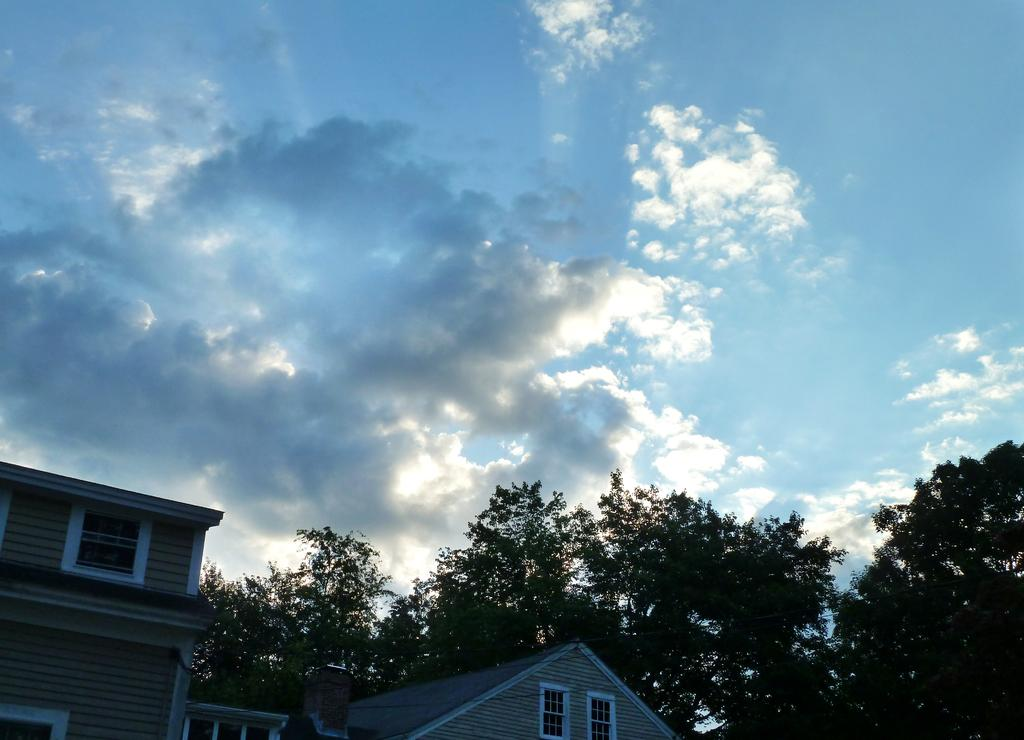What type of structures can be seen in the image? There are buildings in the image. What type of vegetation is present in the image? There are trees in the image. What can be seen in the sky in the image? There are clouds visible in the sky in the image. What is the purpose of the twig in the image? There is no twig present in the image. Can you tell me the account number of the building in the image? There is no account number associated with the building in the image. 